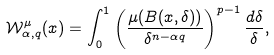Convert formula to latex. <formula><loc_0><loc_0><loc_500><loc_500>\mathcal { W } _ { \alpha , q } ^ { \mu } ( x ) = \int _ { 0 } ^ { 1 } \left ( \frac { \mu ( B ( x , \delta ) ) } { \delta ^ { n - \alpha q } } \right ) ^ { p - 1 } \frac { d \delta } { \delta } ,</formula> 